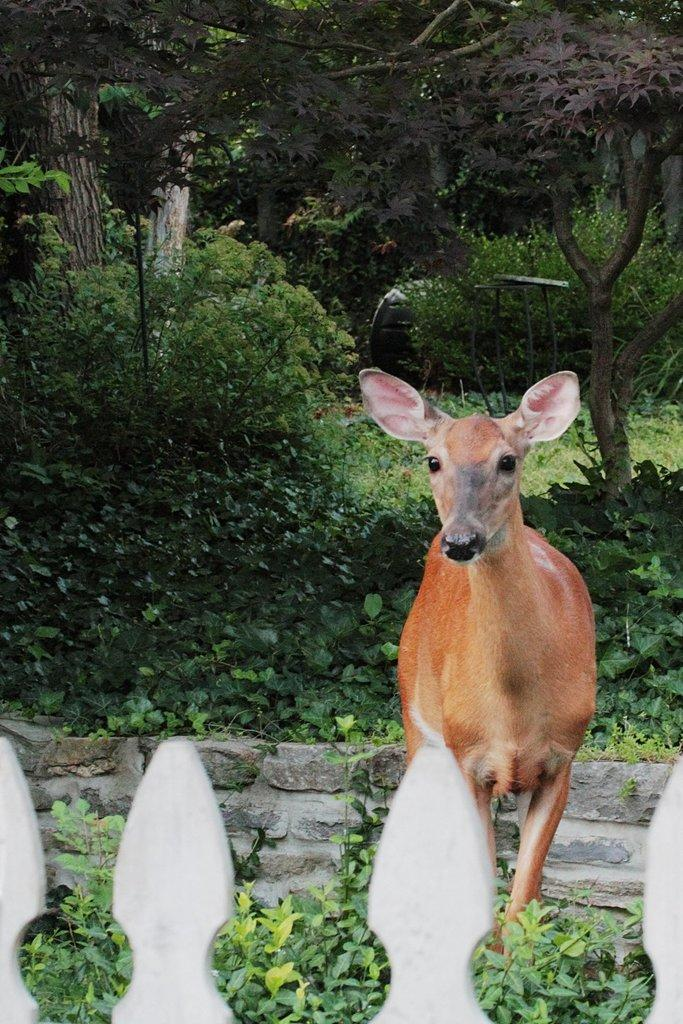What is the main subject in the foreground of the image? There is a deer in the foreground of the image. What else can be seen in the foreground of the image? There are plants and a railing in the foreground of the image. What is visible in the background of the image? There are trees and plants in the background of the image. What type of war is being fought in the background of the image? There is no war present in the image; it features a deer, plants, and a railing in the foreground, and trees and plants in the background. Can you tell me how many clams are visible in the image? There are no clams present in the image. 